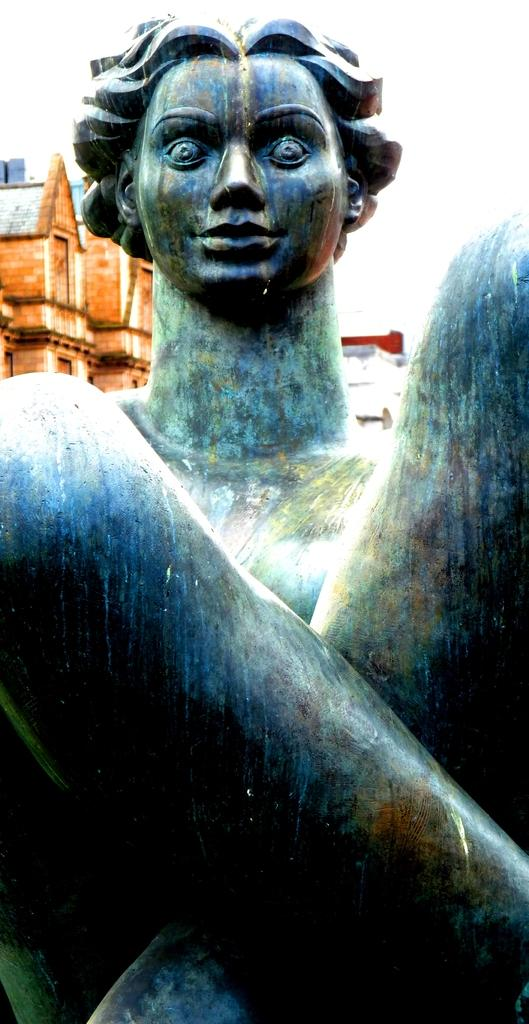What is the main subject of the image? There is a statue of a person in the image. What can be seen in the background of the image? There are buildings in the background of the image. What type of debt is the statue holding in the image? There is no debt present in the image; it features a statue of a person. What type of pickle can be seen on the statue's head in the image? There is no pickle present on the statue's head in the image; it is a statue of a person without any additional objects. 